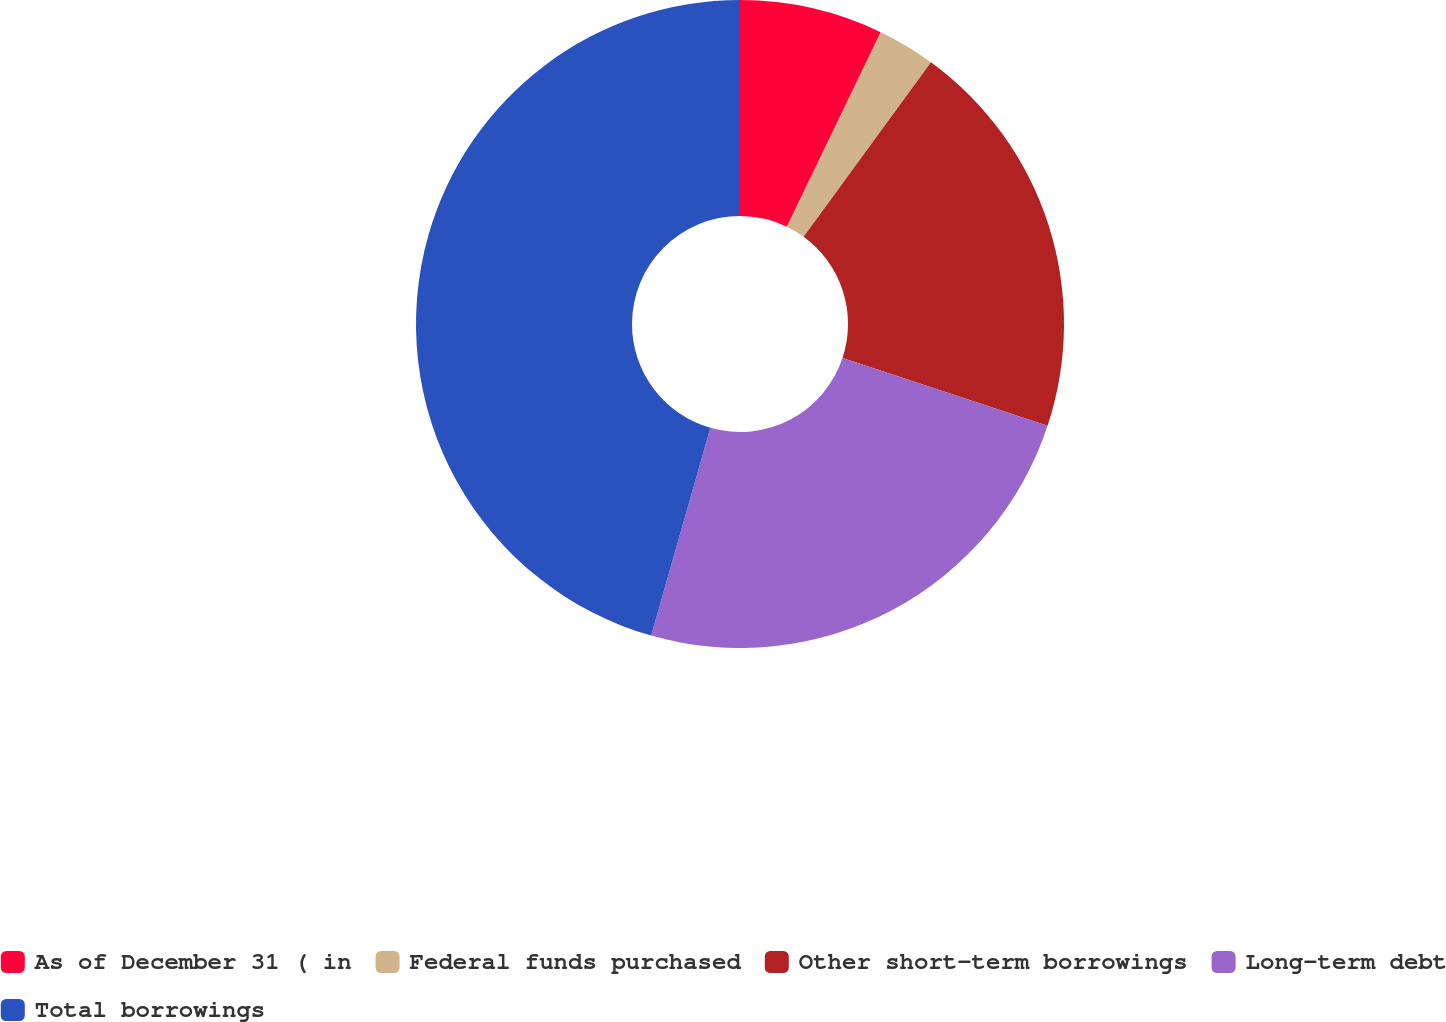<chart> <loc_0><loc_0><loc_500><loc_500><pie_chart><fcel>As of December 31 ( in<fcel>Federal funds purchased<fcel>Other short-term borrowings<fcel>Long-term debt<fcel>Total borrowings<nl><fcel>7.15%<fcel>2.88%<fcel>20.06%<fcel>24.33%<fcel>45.58%<nl></chart> 